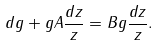<formula> <loc_0><loc_0><loc_500><loc_500>d g + g A \frac { d z } { z } = B g \frac { d z } { z } .</formula> 